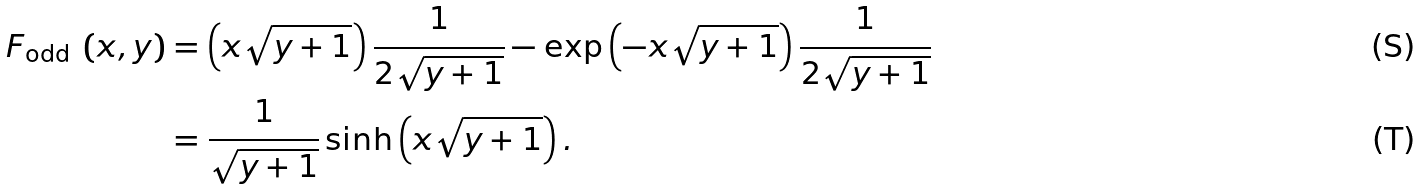Convert formula to latex. <formula><loc_0><loc_0><loc_500><loc_500>F _ { \text {odd } } \left ( x , y \right ) & = \left ( x \sqrt { y + 1 } \right ) \frac { 1 } { 2 \sqrt { y + 1 } } - \exp \left ( - x \sqrt { y + 1 } \right ) \frac { 1 } { 2 \sqrt { y + 1 } } \\ & = \frac { 1 } { \sqrt { y + 1 } } \sinh \left ( x \sqrt { y + 1 } \right ) .</formula> 